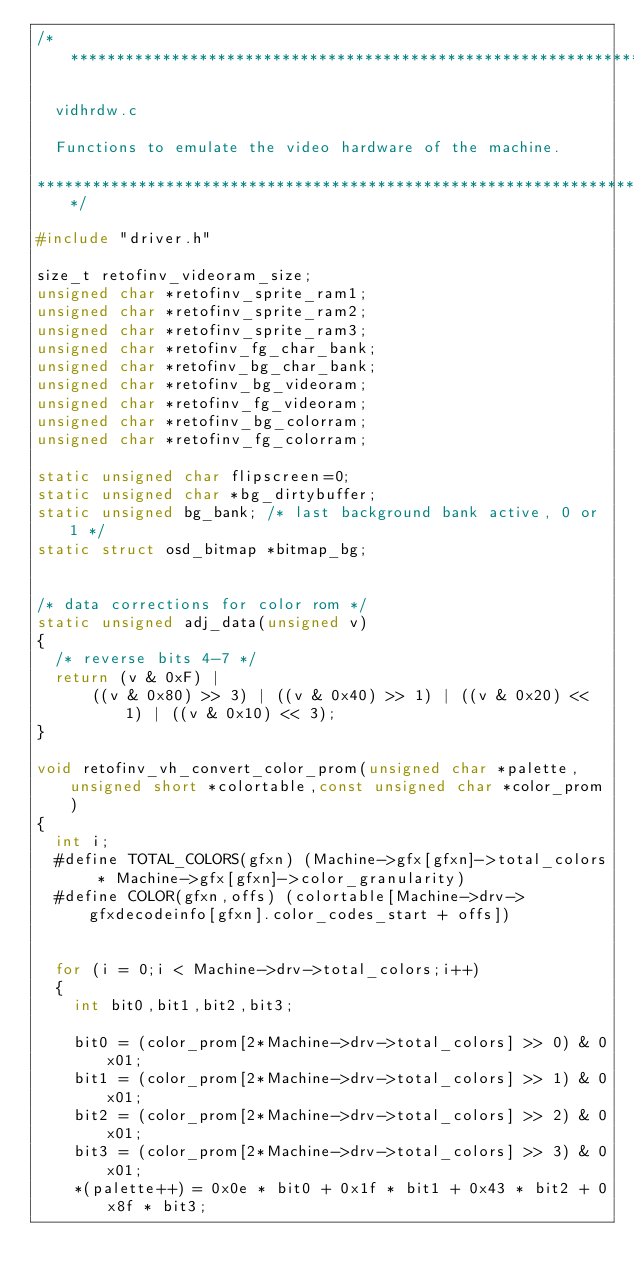Convert code to text. <code><loc_0><loc_0><loc_500><loc_500><_C++_>/***************************************************************************

  vidhrdw.c

  Functions to emulate the video hardware of the machine.

***************************************************************************/

#include "driver.h"

size_t retofinv_videoram_size;
unsigned char *retofinv_sprite_ram1;
unsigned char *retofinv_sprite_ram2;
unsigned char *retofinv_sprite_ram3;
unsigned char *retofinv_fg_char_bank;
unsigned char *retofinv_bg_char_bank;
unsigned char *retofinv_bg_videoram;
unsigned char *retofinv_fg_videoram;
unsigned char *retofinv_bg_colorram;
unsigned char *retofinv_fg_colorram;

static unsigned char flipscreen=0;
static unsigned char *bg_dirtybuffer;
static unsigned bg_bank; /* last background bank active, 0 or 1 */
static struct osd_bitmap *bitmap_bg;


/* data corrections for color rom */
static unsigned adj_data(unsigned v)
{
	/* reverse bits 4-7 */
	return (v & 0xF) |
			((v & 0x80) >> 3) | ((v & 0x40) >> 1) | ((v & 0x20) << 1) | ((v & 0x10) << 3);
}

void retofinv_vh_convert_color_prom(unsigned char *palette, unsigned short *colortable,const unsigned char *color_prom)
{
	int i;
	#define TOTAL_COLORS(gfxn) (Machine->gfx[gfxn]->total_colors * Machine->gfx[gfxn]->color_granularity)
	#define COLOR(gfxn,offs) (colortable[Machine->drv->gfxdecodeinfo[gfxn].color_codes_start + offs])


	for (i = 0;i < Machine->drv->total_colors;i++)
	{
		int bit0,bit1,bit2,bit3;

		bit0 = (color_prom[2*Machine->drv->total_colors] >> 0) & 0x01;
		bit1 = (color_prom[2*Machine->drv->total_colors] >> 1) & 0x01;
		bit2 = (color_prom[2*Machine->drv->total_colors] >> 2) & 0x01;
		bit3 = (color_prom[2*Machine->drv->total_colors] >> 3) & 0x01;
		*(palette++) = 0x0e * bit0 + 0x1f * bit1 + 0x43 * bit2 + 0x8f * bit3;
</code> 